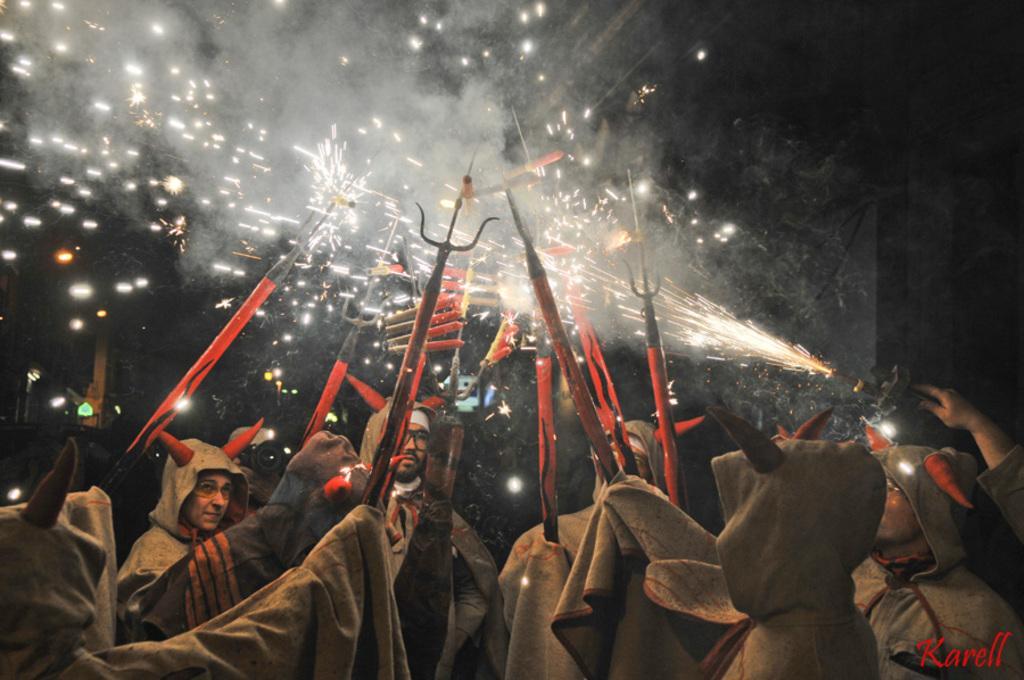Can you describe this image briefly? In this given image, we can see a group of people standing and holding an iron metal objects in their hands after that, we can see few firecrackers next we can see artificial horns placed on everyone's head. 